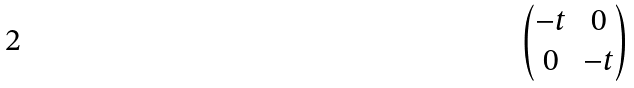<formula> <loc_0><loc_0><loc_500><loc_500>\begin{pmatrix} - t & 0 \\ 0 & - t \end{pmatrix}</formula> 